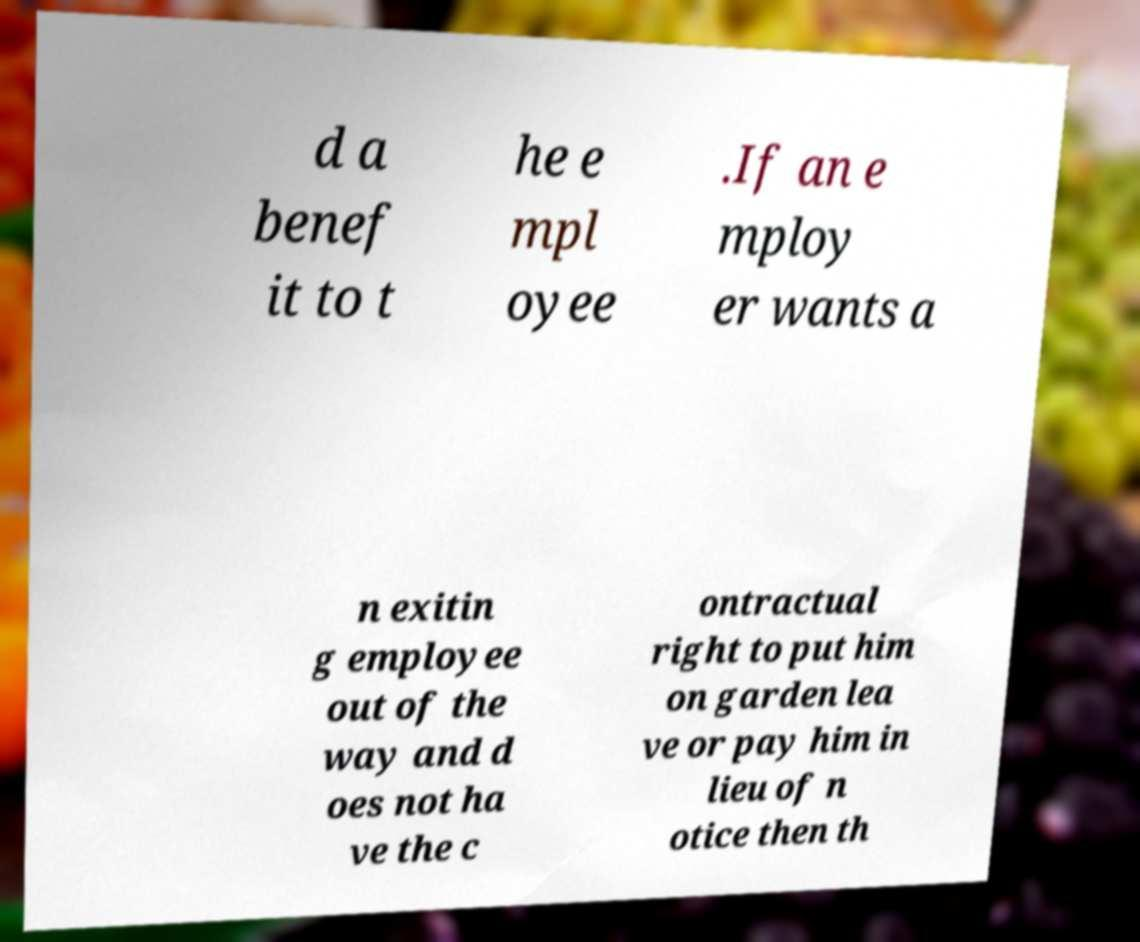For documentation purposes, I need the text within this image transcribed. Could you provide that? d a benef it to t he e mpl oyee .If an e mploy er wants a n exitin g employee out of the way and d oes not ha ve the c ontractual right to put him on garden lea ve or pay him in lieu of n otice then th 